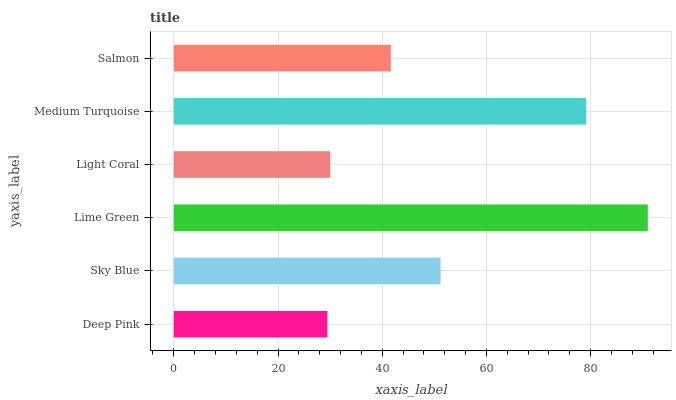Is Deep Pink the minimum?
Answer yes or no. Yes. Is Lime Green the maximum?
Answer yes or no. Yes. Is Sky Blue the minimum?
Answer yes or no. No. Is Sky Blue the maximum?
Answer yes or no. No. Is Sky Blue greater than Deep Pink?
Answer yes or no. Yes. Is Deep Pink less than Sky Blue?
Answer yes or no. Yes. Is Deep Pink greater than Sky Blue?
Answer yes or no. No. Is Sky Blue less than Deep Pink?
Answer yes or no. No. Is Sky Blue the high median?
Answer yes or no. Yes. Is Salmon the low median?
Answer yes or no. Yes. Is Lime Green the high median?
Answer yes or no. No. Is Medium Turquoise the low median?
Answer yes or no. No. 